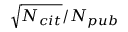Convert formula to latex. <formula><loc_0><loc_0><loc_500><loc_500>\sqrt { N _ { c i t } } / N _ { p u b }</formula> 